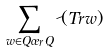<formula> <loc_0><loc_0><loc_500><loc_500>\sum _ { w \in Q \sigma _ { r } Q } \psi ( T r w )</formula> 